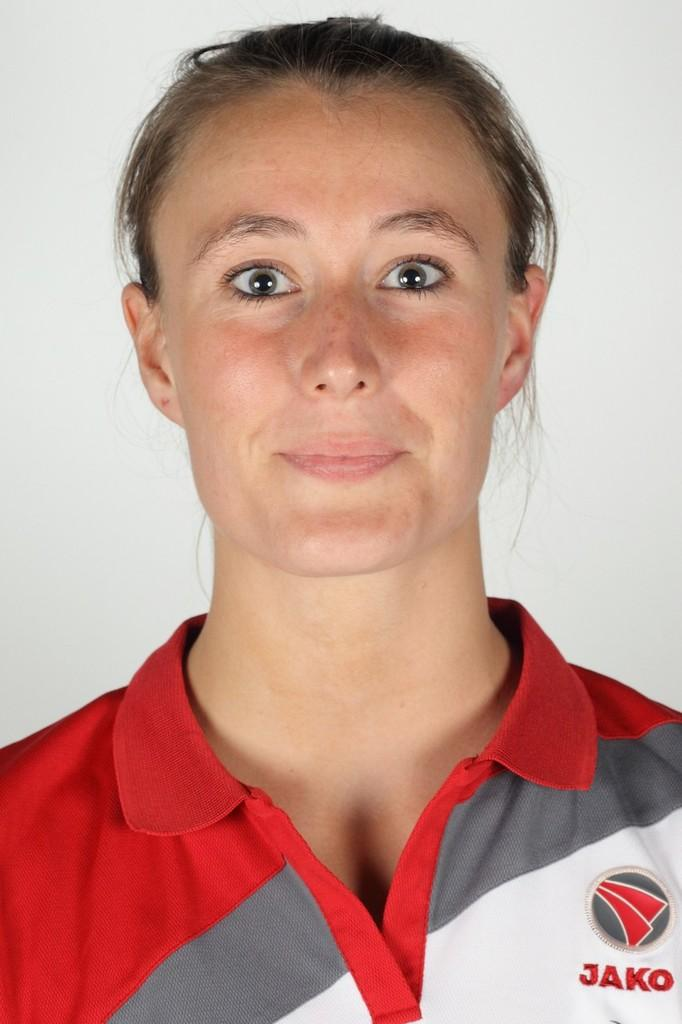Provide a one-sentence caption for the provided image. A woman wearing a collared shirt that says JAKO poses for the camera. 